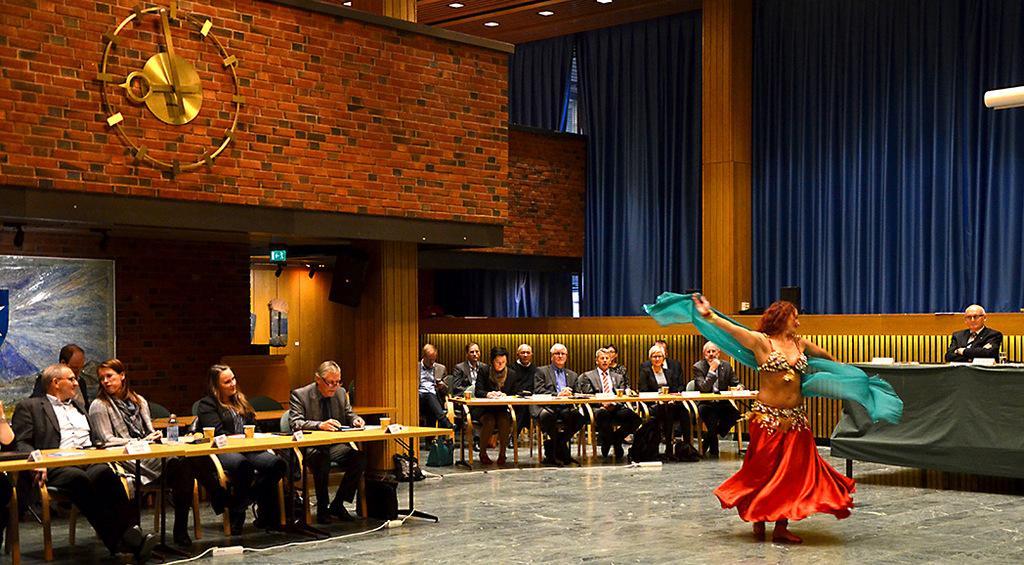In one or two sentences, can you explain what this image depicts? In this image there are group of persons sitting on the chair and at the right side of the image there is a lady person wearing red color dress dancing and at the top of the image there is a red color brick wall and blue color curtain. 